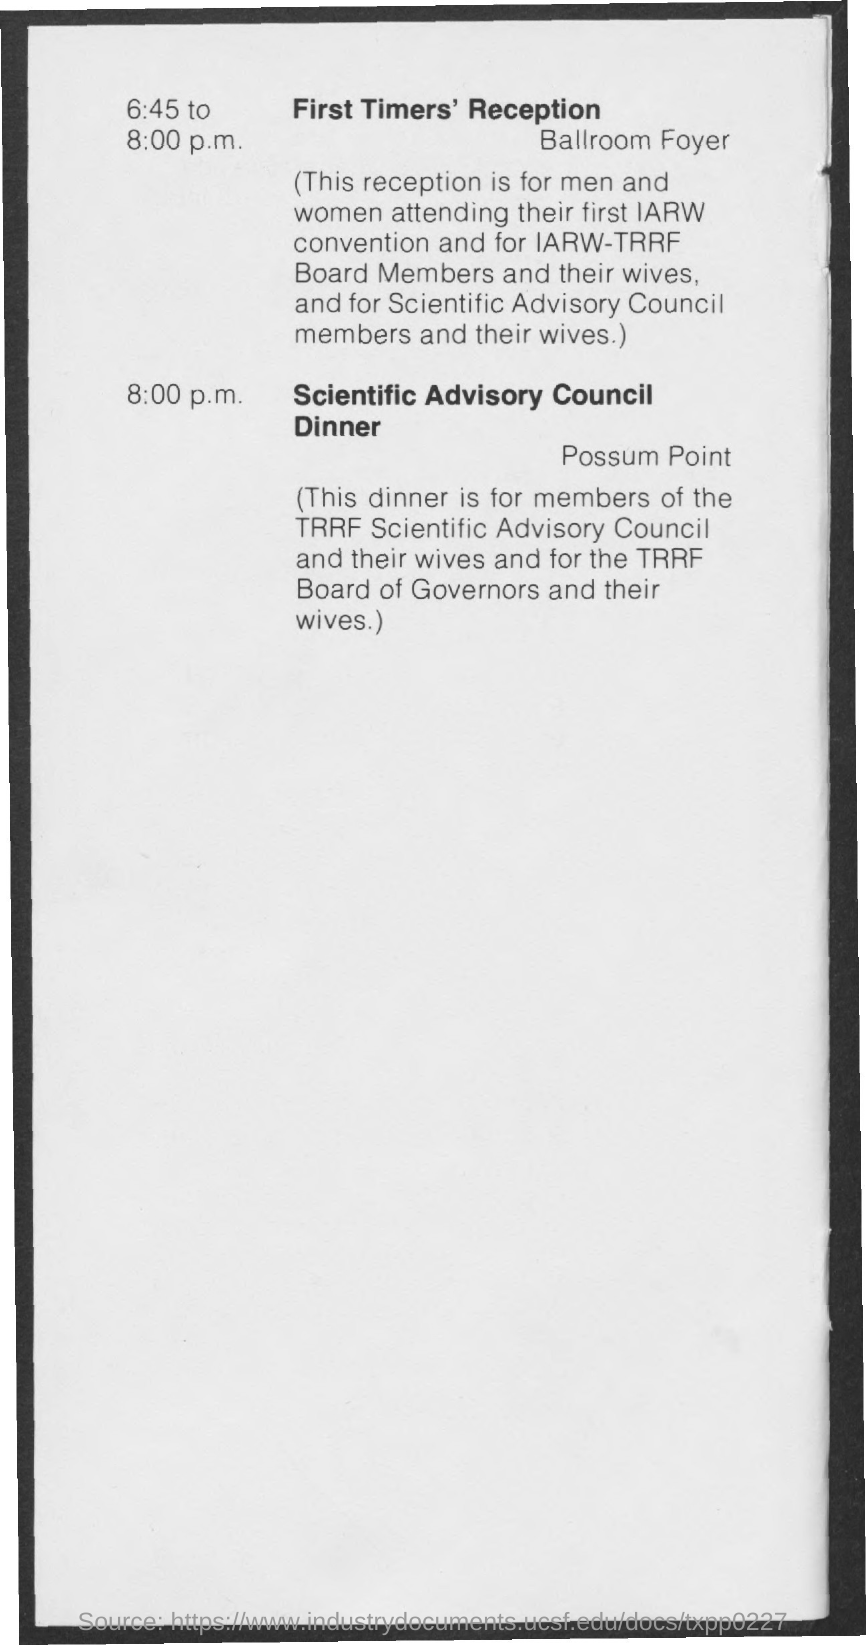Specify some key components in this picture. The First Timers' Reception will be held in the ballroom foyer. The "Scientific Advisory Council Dinner" will be held at "Possum Point". The Scientific Advisory Council Dinner is scheduled to take place at 8:00 p.m. The dinner is for members of the TRRF Scientific Advisory Council. The First Timers' Reception is scheduled to begin at 6:45 p.m. 